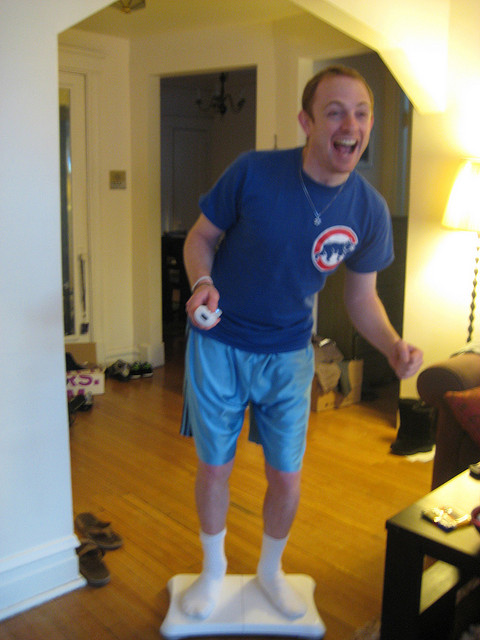<image>What color is the bag on the floor? There is no bag on the floor in the image. However, it can be seen as white, brown or black. What color is the bag on the floor? It is ambiguous what color the bag on the floor is. It can be seen white, brown or black. 